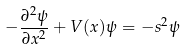Convert formula to latex. <formula><loc_0><loc_0><loc_500><loc_500>- \frac { \partial ^ { 2 } \psi } { \partial x ^ { 2 } } + V ( x ) \psi = - s ^ { 2 } \psi</formula> 